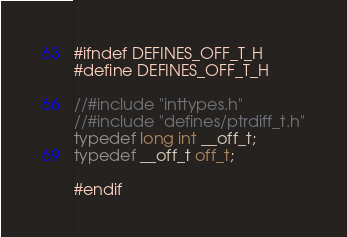<code> <loc_0><loc_0><loc_500><loc_500><_C_>#ifndef DEFINES_OFF_T_H
#define DEFINES_OFF_T_H

//#include "inttypes.h"
//#include "defines/ptrdiff_t.h"
typedef long int __off_t;
typedef __off_t off_t;

#endif</code> 